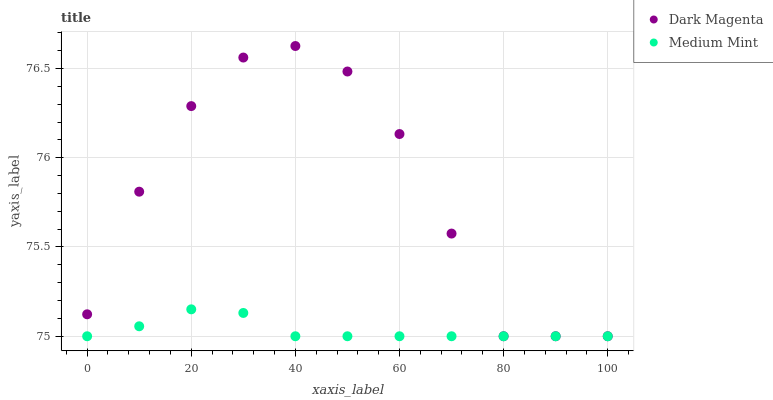Does Medium Mint have the minimum area under the curve?
Answer yes or no. Yes. Does Dark Magenta have the maximum area under the curve?
Answer yes or no. Yes. Does Dark Magenta have the minimum area under the curve?
Answer yes or no. No. Is Medium Mint the smoothest?
Answer yes or no. Yes. Is Dark Magenta the roughest?
Answer yes or no. Yes. Is Dark Magenta the smoothest?
Answer yes or no. No. Does Medium Mint have the lowest value?
Answer yes or no. Yes. Does Dark Magenta have the highest value?
Answer yes or no. Yes. Does Medium Mint intersect Dark Magenta?
Answer yes or no. Yes. Is Medium Mint less than Dark Magenta?
Answer yes or no. No. Is Medium Mint greater than Dark Magenta?
Answer yes or no. No. 